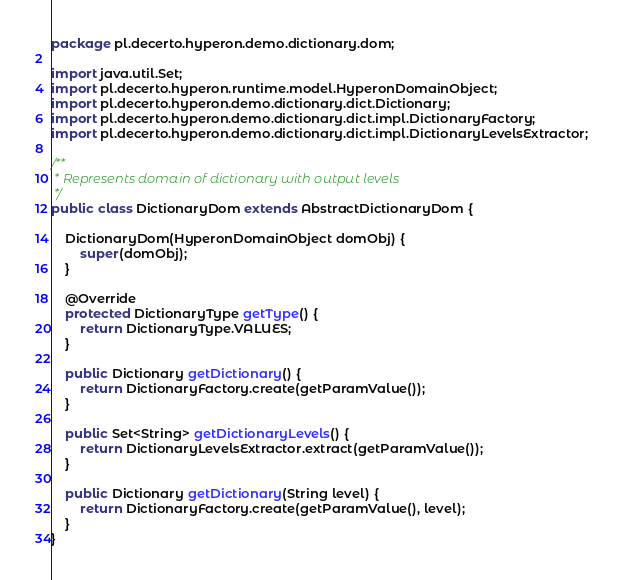Convert code to text. <code><loc_0><loc_0><loc_500><loc_500><_Java_>package pl.decerto.hyperon.demo.dictionary.dom;

import java.util.Set;
import pl.decerto.hyperon.runtime.model.HyperonDomainObject;
import pl.decerto.hyperon.demo.dictionary.dict.Dictionary;
import pl.decerto.hyperon.demo.dictionary.dict.impl.DictionaryFactory;
import pl.decerto.hyperon.demo.dictionary.dict.impl.DictionaryLevelsExtractor;

/**
 * Represents domain of dictionary with output levels
 */
public class DictionaryDom extends AbstractDictionaryDom {

	DictionaryDom(HyperonDomainObject domObj) {
		super(domObj);
	}

	@Override
	protected DictionaryType getType() {
		return DictionaryType.VALUES;
	}

	public Dictionary getDictionary() {
		return DictionaryFactory.create(getParamValue());
	}

	public Set<String> getDictionaryLevels() {
		return DictionaryLevelsExtractor.extract(getParamValue());
	}

	public Dictionary getDictionary(String level) {
		return DictionaryFactory.create(getParamValue(), level);
	}
}
</code> 